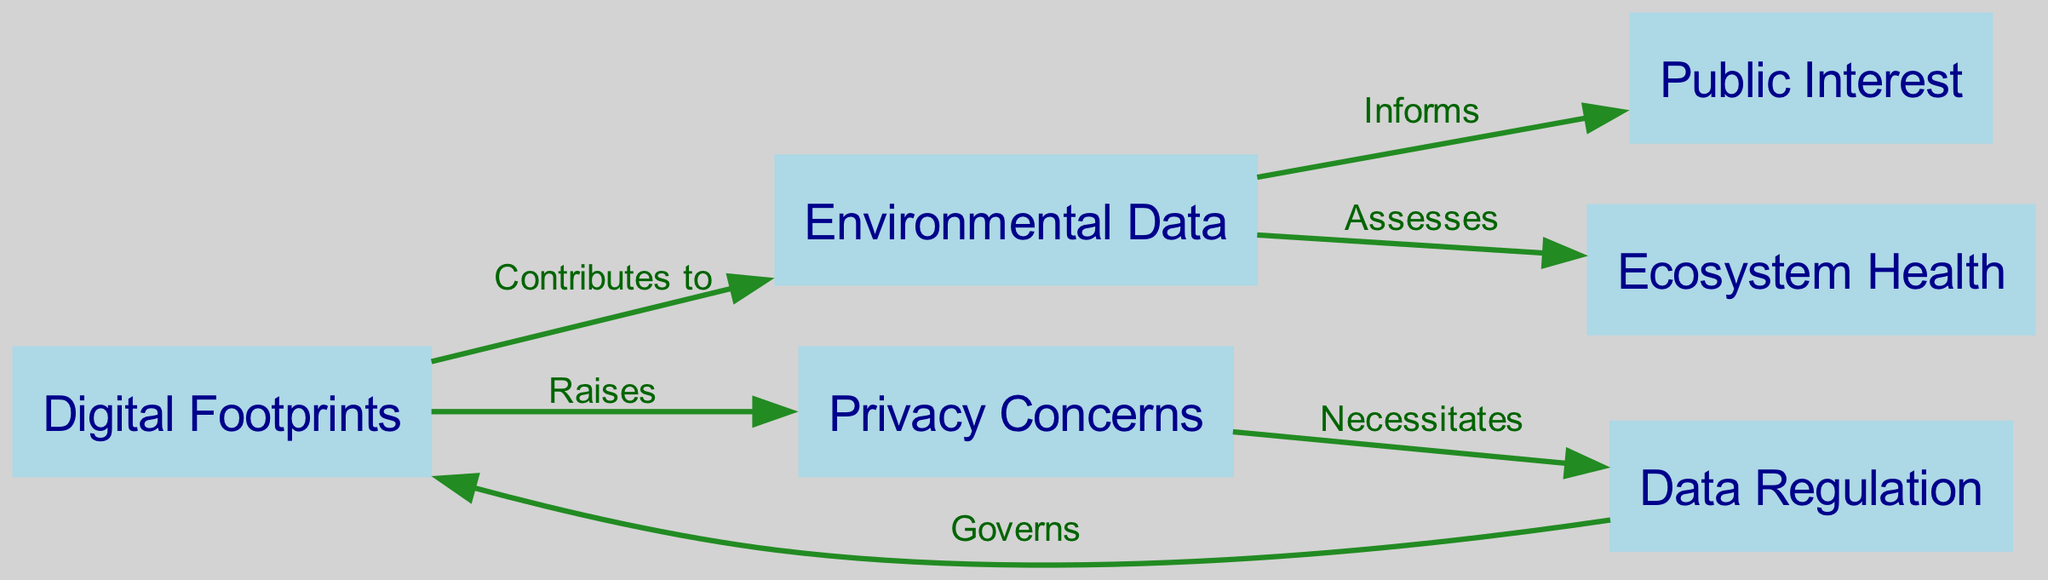What are the nodes in the diagram? The nodes are presented clearly in the diagram, comprising Digital Footprints, Environmental Data, Privacy Concerns, Public Interest, Data Regulation, and Ecosystem Health.
Answer: Digital Footprints, Environmental Data, Privacy Concerns, Public Interest, Data Regulation, Ecosystem Health How many edges are there in the diagram? The diagram depicts a total of 6 edges that connect the nodes. Each edge signifies a relationship between two nodes.
Answer: 6 What does Digital Footprints contribute to? According to the diagram, Digital Footprints contributes to Environmental Data, indicating a flow of information or influence from one node to another.
Answer: Environmental Data Which node raises Privacy Concerns? The component labeled Digital Footprints is responsible for raising Privacy Concerns in the ecosystem model illustrated in the diagram.
Answer: Digital Footprints What does Environmental Data assess? The diagram indicates that Environmental Data assesses Ecosystem Health, revealing the link between environmental metrics and the overall health of ecosystems.
Answer: Ecosystem Health What necessitates data regulation? The diagram shows that Privacy Concerns necessitate data regulation, highlighting the relationship between issues of privacy and the need for regulatory measures.
Answer: Privacy Concerns What informs Public Interest? According to the diagram, Environmental Data informs Public Interest, demonstrating how environmental insights can shape societal values and interests.
Answer: Environmental Data Which node governs Digital Footprints? The diagram indicates that Data Regulation governs Digital Footprints, implying regulatory oversight over digital activities and footprints.
Answer: Data Regulation How is the relationship between Environmental Data and Ecosystem Health described? The relationship is described as assessing, indicating that Environmental Data plays a crucial role in evaluating the health of ecosystems.
Answer: Assesses 